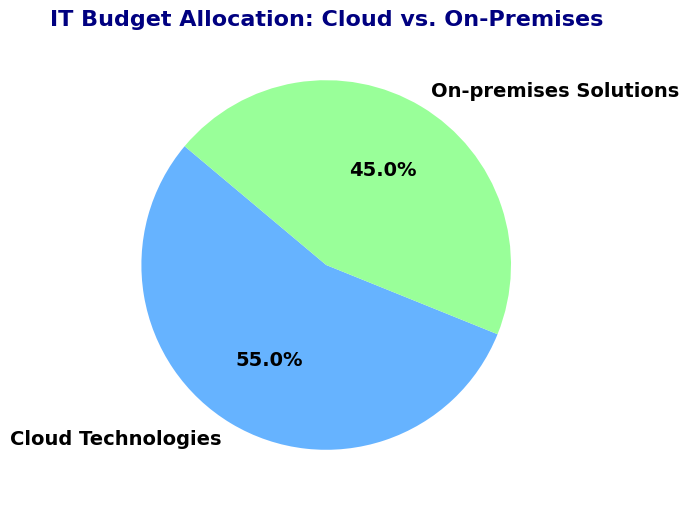Which category receives the highest percentage of the IT budget? The figure has two categories: Cloud Technologies and On-premises Solutions. By comparing their percentages, we see that Cloud Technologies has 55% while On-premises Solutions has 45%. Hence, Cloud Technologies receives the highest percentage.
Answer: Cloud Technologies What's the percentage difference between Cloud Technologies and On-premises Solutions in the IT budget allocation? Subtract the percentage of On-premises Solutions (45%) from Cloud Technologies (55%), which results in a difference of 10%.
Answer: 10% If the IT budget is $1,000,000, how much money is allocated to On-premises Solutions? Calculate 45% of $1,000,000: (45/100) * 1,000,000 = $450,000.
Answer: $450,000 How much more is allocated to Cloud Technologies compared to On-premises Solutions? First, find the dollar amounts for each: Cloud Technologies is 55% of $1,000,000, which is $550,000. On-premises Solutions is 45% of $1,000,000, which is $450,000. Subtract the two: $550,000 - $450,000 = $100,000.
Answer: $100,000 What is the ratio of the budget allocation between Cloud Technologies and On-premises Solutions? The ratio can be determined by dividing the percentages: 55% (Cloud Technologies) to 45% (On-premises Solutions), which simplifies to 55:45 or further to 11:9.
Answer: 11:9 Is the percentage allocated to Cloud Technologies greater than 50%? The chart shows Cloud Technologies allocated at 55%, which is indeed greater than 50%.
Answer: Yes What percentage of the IT budget is not allocated to Cloud Technologies? Since Cloud Technologies receives 55%, subtract from the total budget: 100% - 55% = 45%, which is allocated to other categories.
Answer: 45% Which budget allocation category is represented by a lighter shade of color in the pie chart? By inspecting the visual colors of the pie chart, Cloud Technologies is represented by a light blue while On-premises Solutions uses a light green. Cloud Technologies has the lighter color.
Answer: Cloud Technologies If the total IT budget increases by 20%, what will be the new budget for Cloud Technologies assuming the percentage allocation remains the same? Calculate 120% of the total budget and then 55% of the increased total budget: First increase the total budget: $1,000,000 * 1.20 = $1,200,000. Then calculate 55% of the new budget: 55/100 * $1,200,000 = $660,000.
Answer: $660,000 What is the sum percentage of both Cloud Technologies and On-premises Solutions? Add both percentages shown on the pie chart: 55% (Cloud Technologies) + 45% (On-premises Solutions) = 100%.
Answer: 100% 